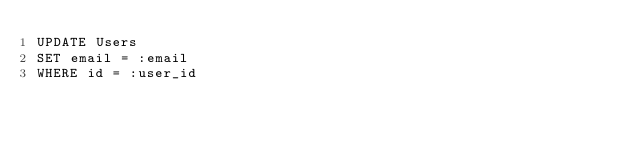<code> <loc_0><loc_0><loc_500><loc_500><_SQL_>UPDATE Users
SET email = :email
WHERE id = :user_id</code> 